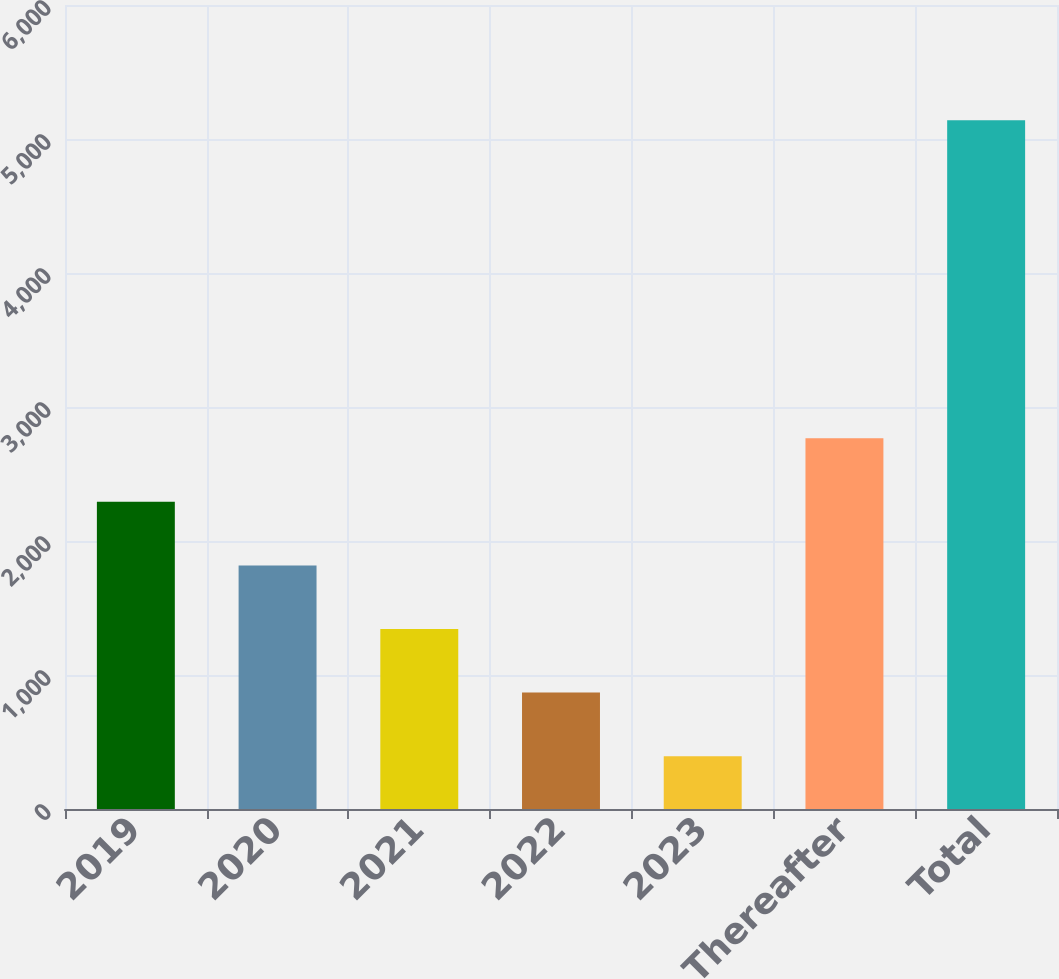Convert chart to OTSL. <chart><loc_0><loc_0><loc_500><loc_500><bar_chart><fcel>2019<fcel>2020<fcel>2021<fcel>2022<fcel>2023<fcel>Thereafter<fcel>Total<nl><fcel>2292<fcel>1817.5<fcel>1343<fcel>868.5<fcel>394<fcel>2766.5<fcel>5139<nl></chart> 